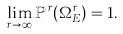Convert formula to latex. <formula><loc_0><loc_0><loc_500><loc_500>\lim _ { r \to \infty } \mathbb { P } ^ { r } ( { \Omega ^ { r } _ { E } } ) = 1 .</formula> 